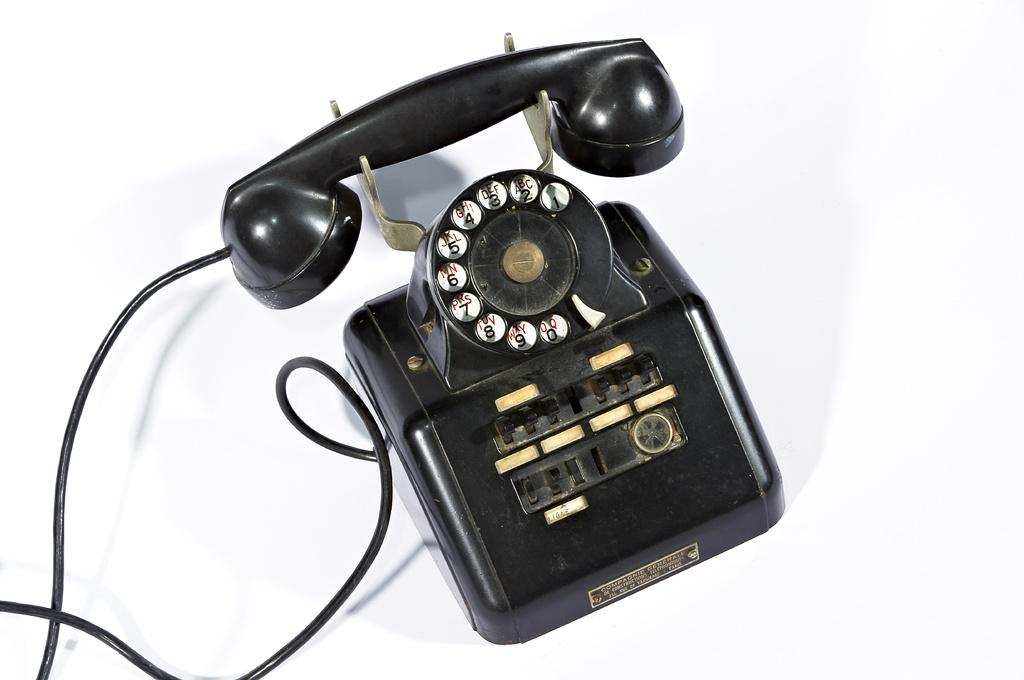<image>
Describe the image concisely. An old, black, telephone with a Compagnie Generale name plate attached to it. 